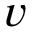<formula> <loc_0><loc_0><loc_500><loc_500>v</formula> 